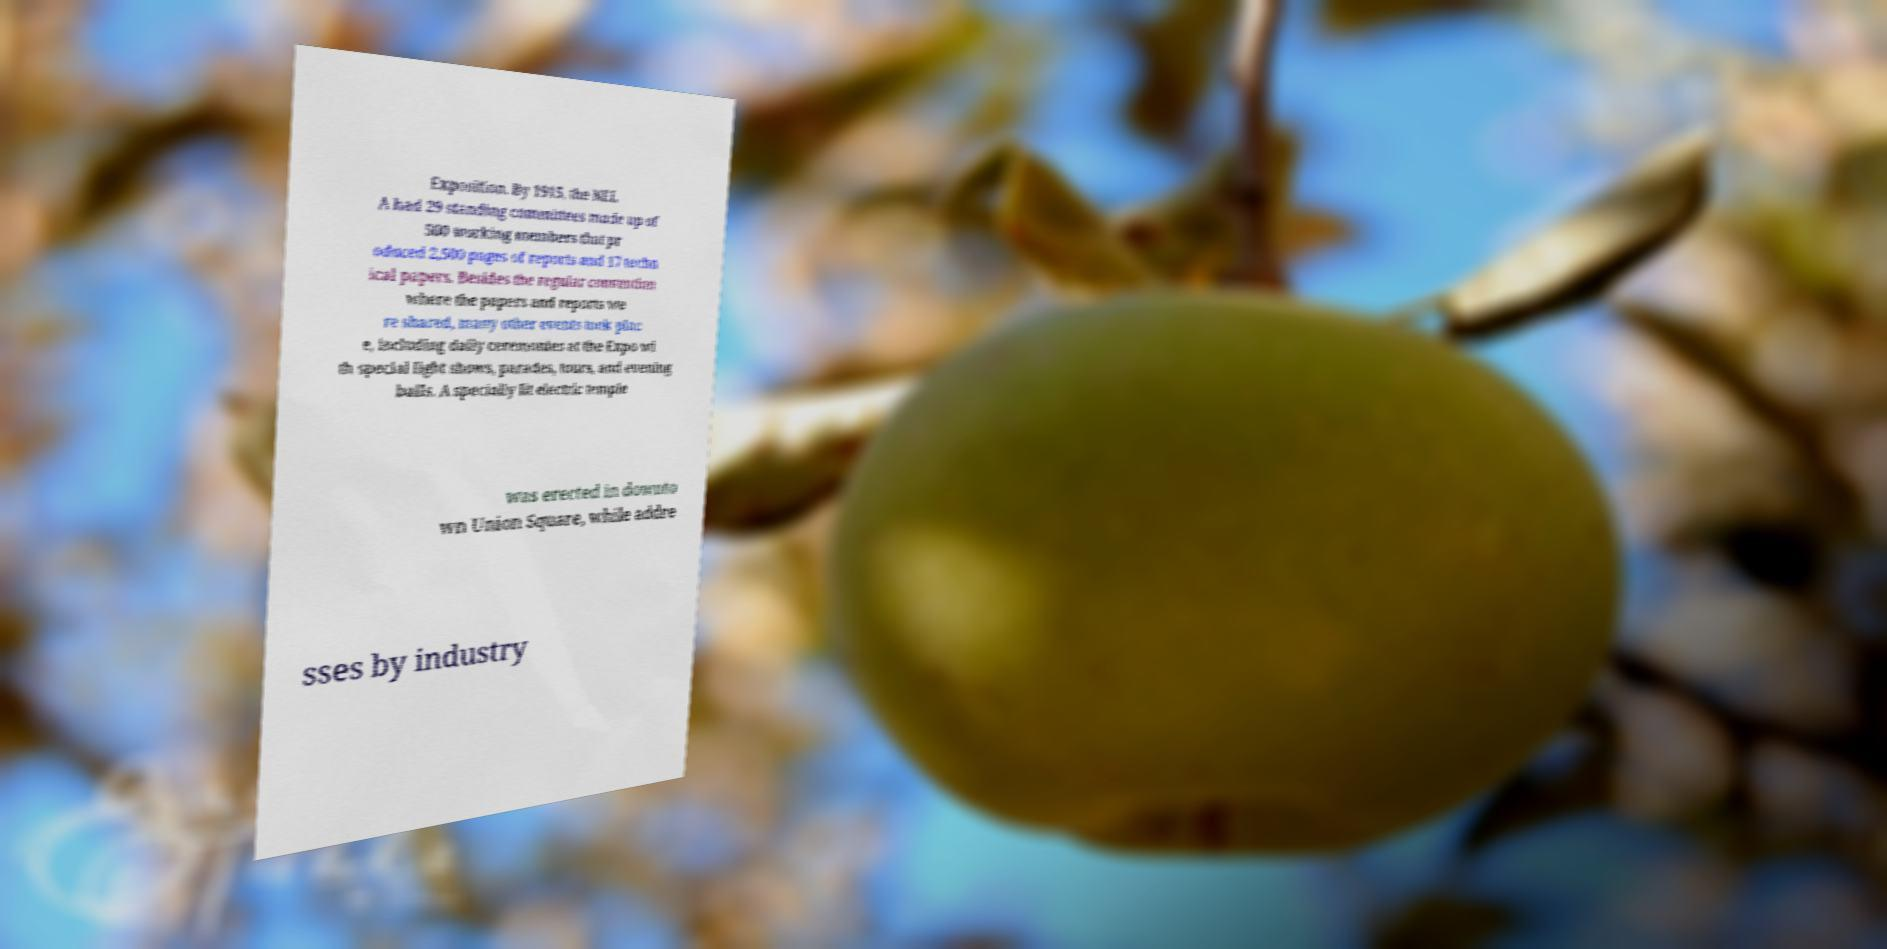Please identify and transcribe the text found in this image. Exposition. By 1915, the NEL A had 29 standing committees made up of 500 working members that pr oduced 2,500 pages of reports and 17 techn ical papers. Besides the regular convention where the papers and reports we re shared, many other events took plac e, including daily ceremonies at the Expo wi th special light shows, parades, tours, and evening balls. A specially lit electric temple was erected in downto wn Union Square, while addre sses by industry 